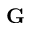<formula> <loc_0><loc_0><loc_500><loc_500>{ G }</formula> 